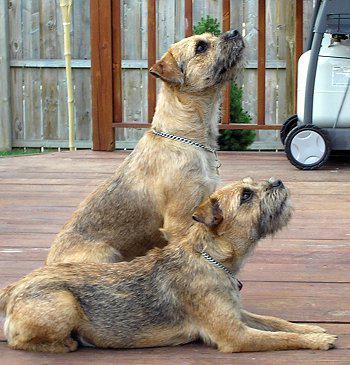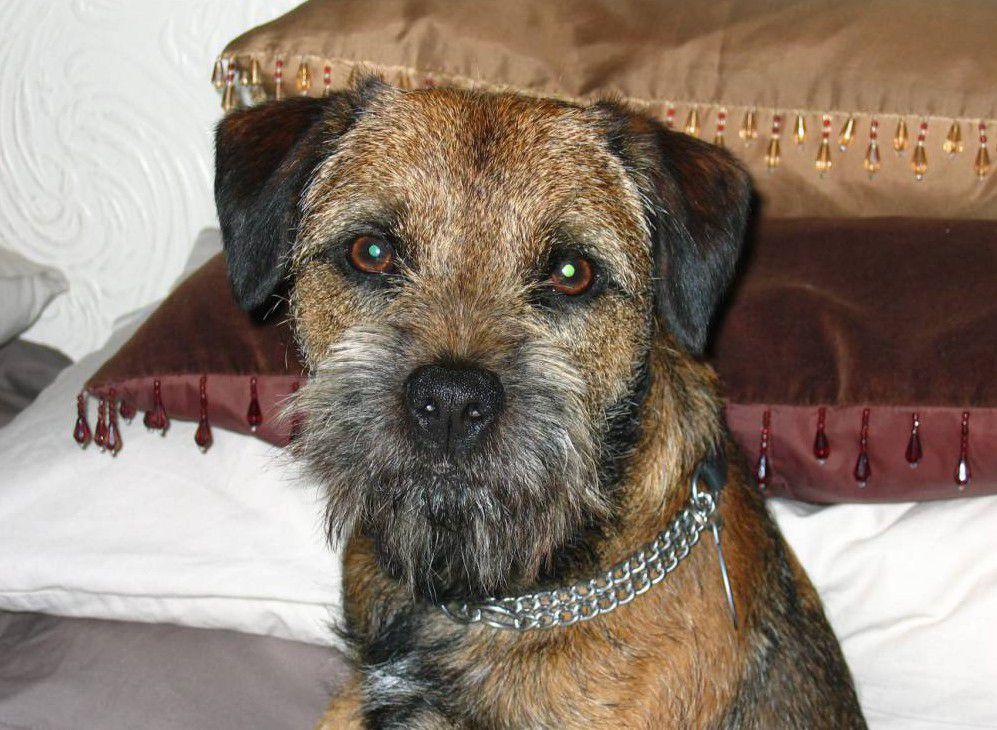The first image is the image on the left, the second image is the image on the right. Assess this claim about the two images: "An image shows a dog in a sleeping pose on a patterned fabric.". Correct or not? Answer yes or no. No. The first image is the image on the left, the second image is the image on the right. Assess this claim about the two images: "There are three dogs,  dog on the right is looking straight at the camera, as if making eye contact.". Correct or not? Answer yes or no. Yes. 